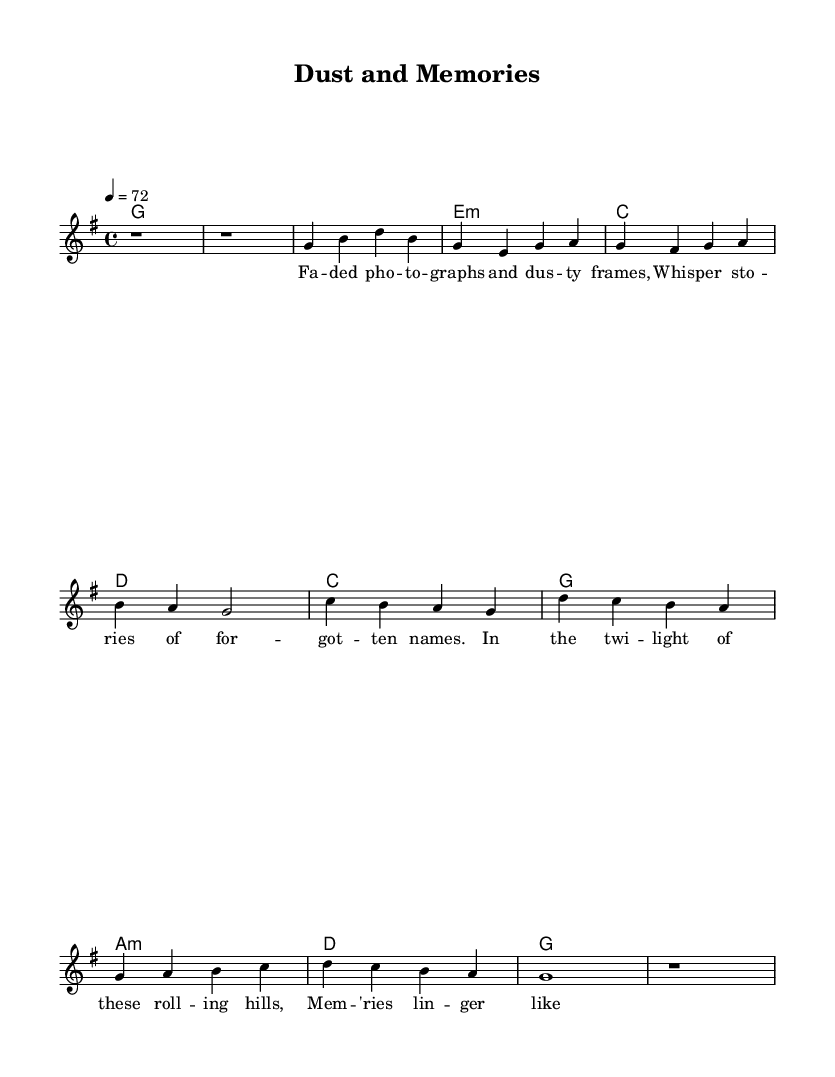What is the key signature of this music? The key signature is G major, which contains one sharp (F#). This can be identified at the beginning of the sheet music.
Answer: G major What is the time signature of this music? The time signature is 4/4, which indicates that there are four beats in each measure. This is commonly seen at the start of the sheet music.
Answer: 4/4 What is the tempo marking of this piece? The tempo marking is 72 beats per minute, indicated by the "4 = 72" at the top of the sheet music. This provides the speed for the performance.
Answer: 72 How many measures does the chorus have? The chorus consists of four measures, which can be counted by looking at the music section labeled "Chorus," which has the chords and melody laid out over four distinct measures.
Answer: Four Which chord appears at the beginning of the verse? The chord at the beginning of the verse is G major, which is found in the chord progression listed under the verse section of the sheet music.
Answer: G How does the lyrical theme reflect Country Rock influences? The lyrics speak to nostalgia and memory, which are common themes in Country Rock music. The introspective nature and poetic phrasing reflect traditional storytelling found in this genre.
Answer: Nostalgia and memory What is the overall structure of the song? The song has an intro, followed by verses and a chorus, and concludes with an outro. This structure is typical in country ballads, where storytelling is highlighted throughout the music.
Answer: Intro, Verse, Chorus, Outro 